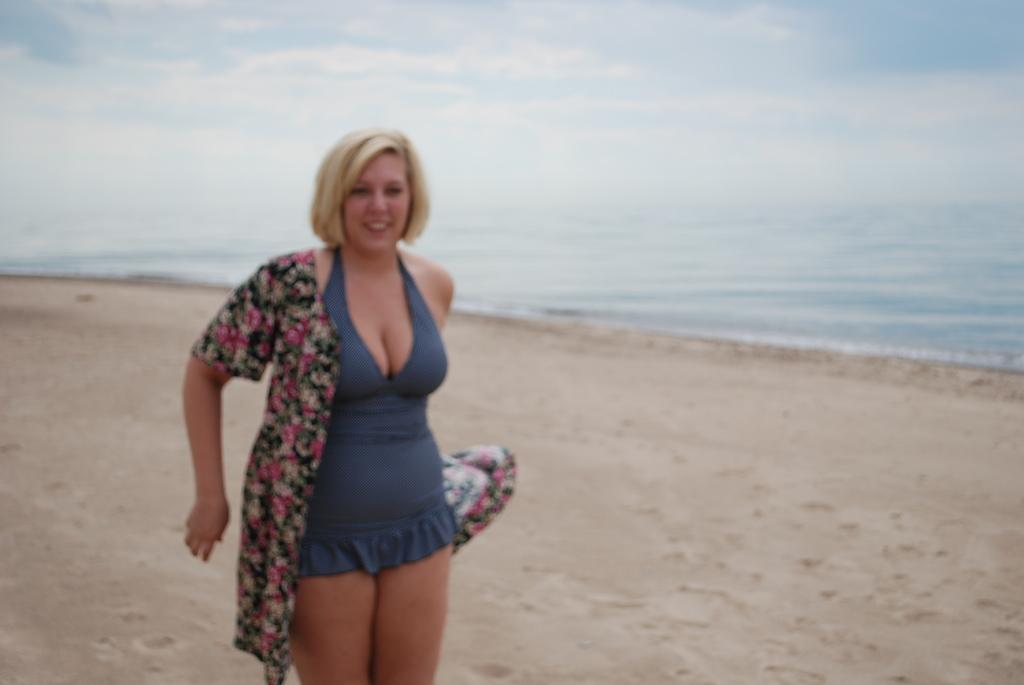Could you give a brief overview of what you see in this image? In this image I can see the person with the dress and the person is standing on the sand. In the background I can see the water, clouds and the sky. 